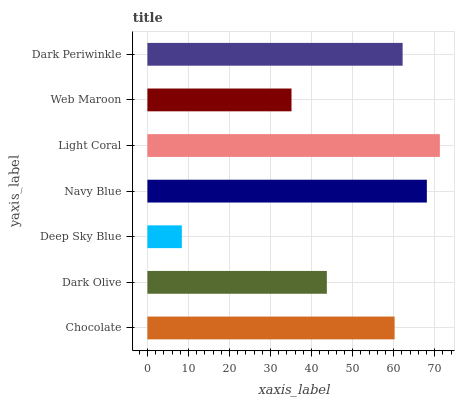Is Deep Sky Blue the minimum?
Answer yes or no. Yes. Is Light Coral the maximum?
Answer yes or no. Yes. Is Dark Olive the minimum?
Answer yes or no. No. Is Dark Olive the maximum?
Answer yes or no. No. Is Chocolate greater than Dark Olive?
Answer yes or no. Yes. Is Dark Olive less than Chocolate?
Answer yes or no. Yes. Is Dark Olive greater than Chocolate?
Answer yes or no. No. Is Chocolate less than Dark Olive?
Answer yes or no. No. Is Chocolate the high median?
Answer yes or no. Yes. Is Chocolate the low median?
Answer yes or no. Yes. Is Deep Sky Blue the high median?
Answer yes or no. No. Is Navy Blue the low median?
Answer yes or no. No. 